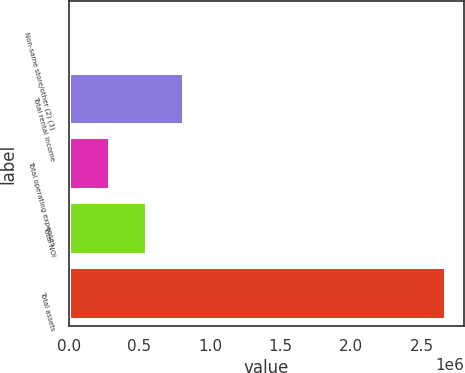Convert chart to OTSL. <chart><loc_0><loc_0><loc_500><loc_500><bar_chart><fcel>Non-same store/other (2) (3)<fcel>Total rental income<fcel>Total operating expenses<fcel>Total NOI<fcel>Total assets<nl><fcel>18042<fcel>812342<fcel>282808<fcel>547575<fcel>2.66571e+06<nl></chart> 